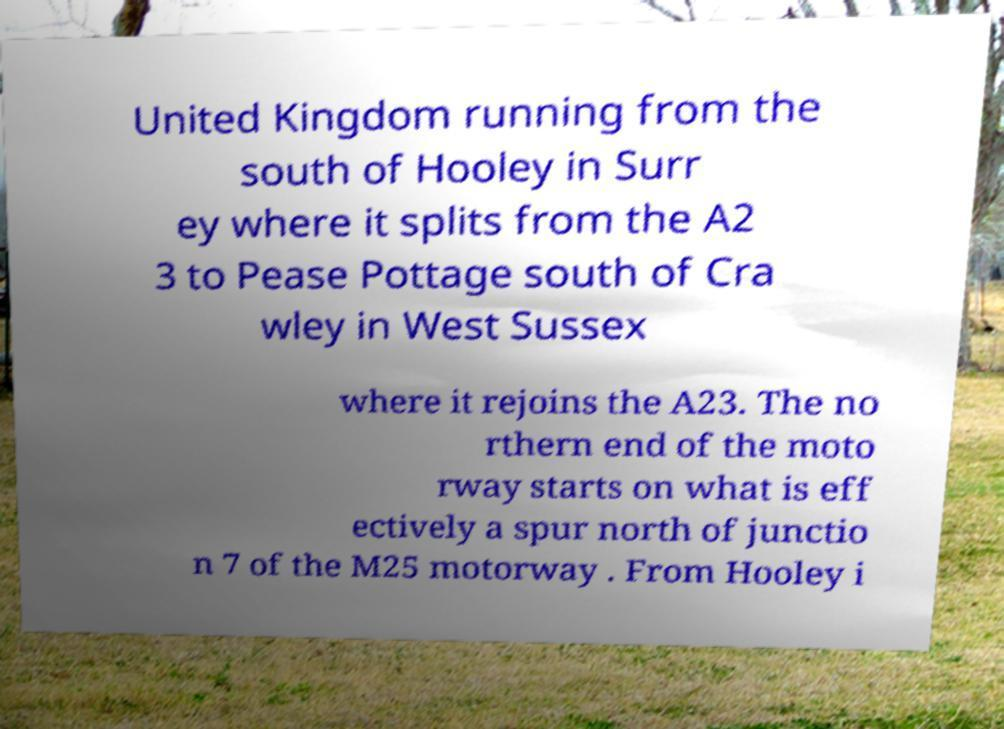Could you extract and type out the text from this image? United Kingdom running from the south of Hooley in Surr ey where it splits from the A2 3 to Pease Pottage south of Cra wley in West Sussex where it rejoins the A23. The no rthern end of the moto rway starts on what is eff ectively a spur north of junctio n 7 of the M25 motorway . From Hooley i 